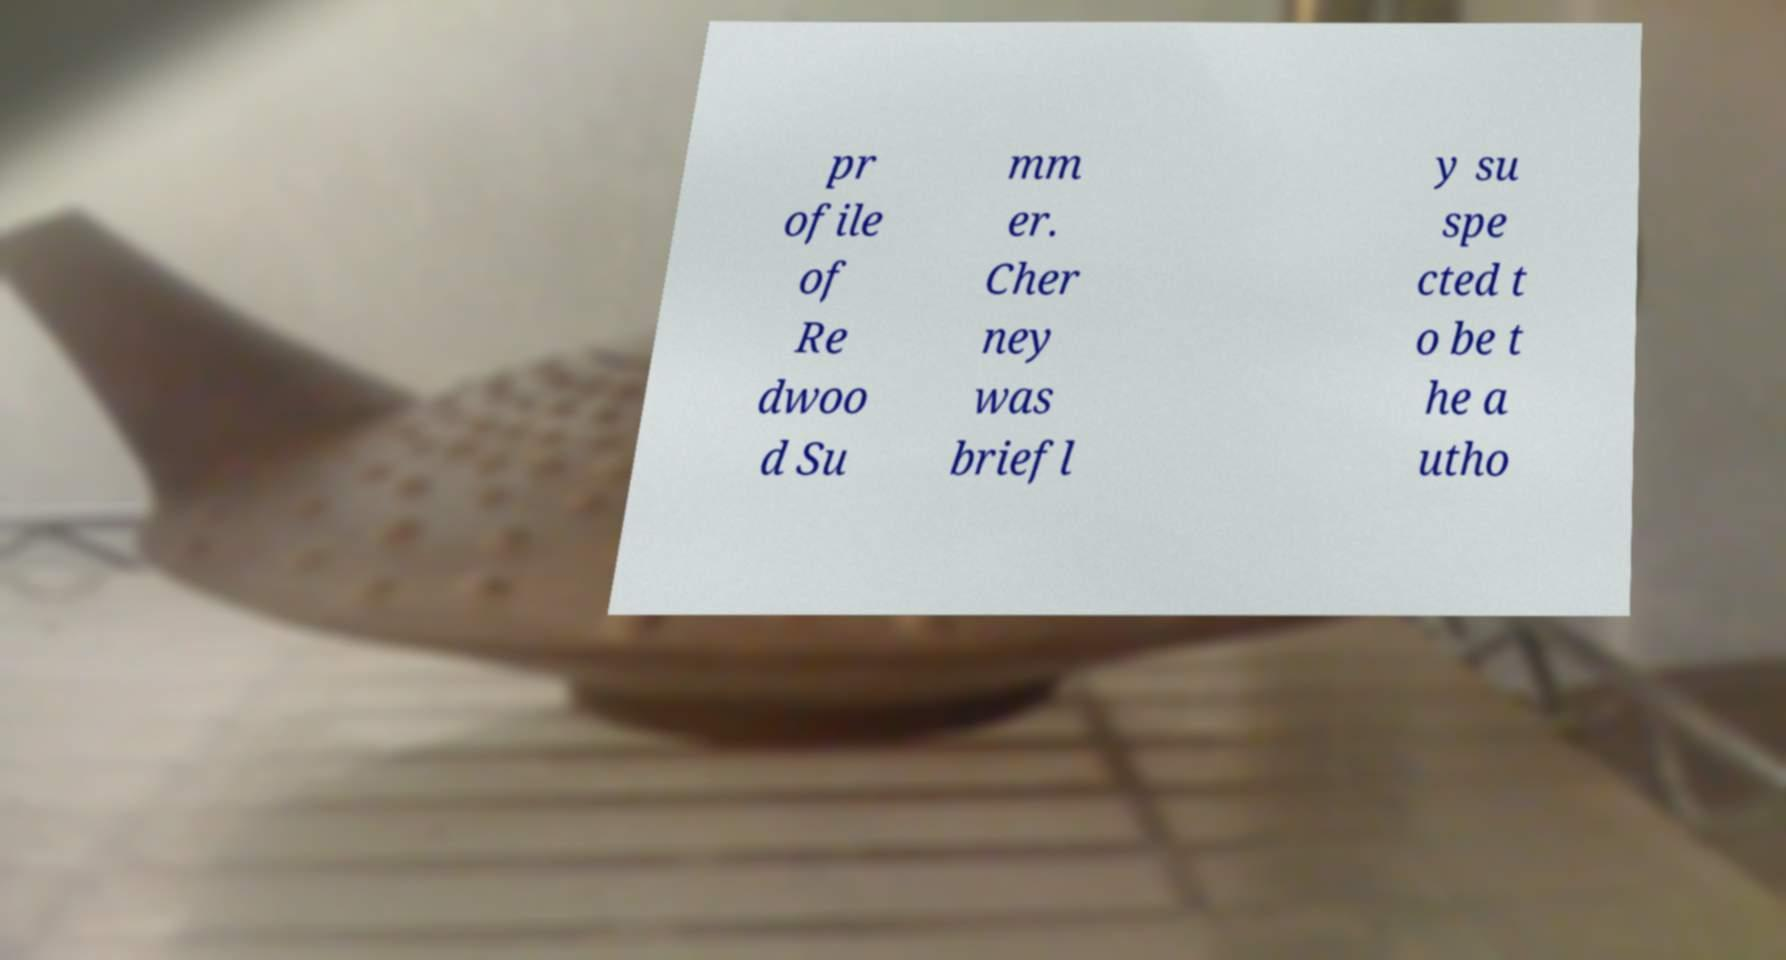Could you extract and type out the text from this image? pr ofile of Re dwoo d Su mm er. Cher ney was briefl y su spe cted t o be t he a utho 